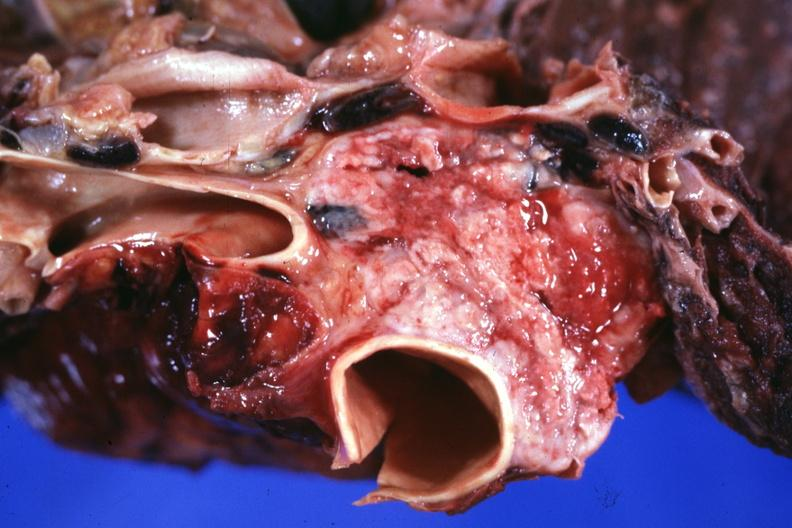what is present?
Answer the question using a single word or phrase. Thymus 